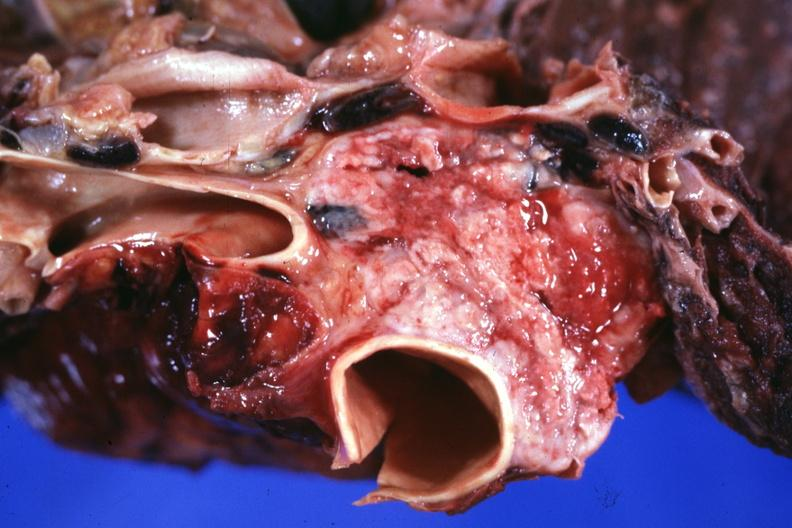what is present?
Answer the question using a single word or phrase. Thymus 